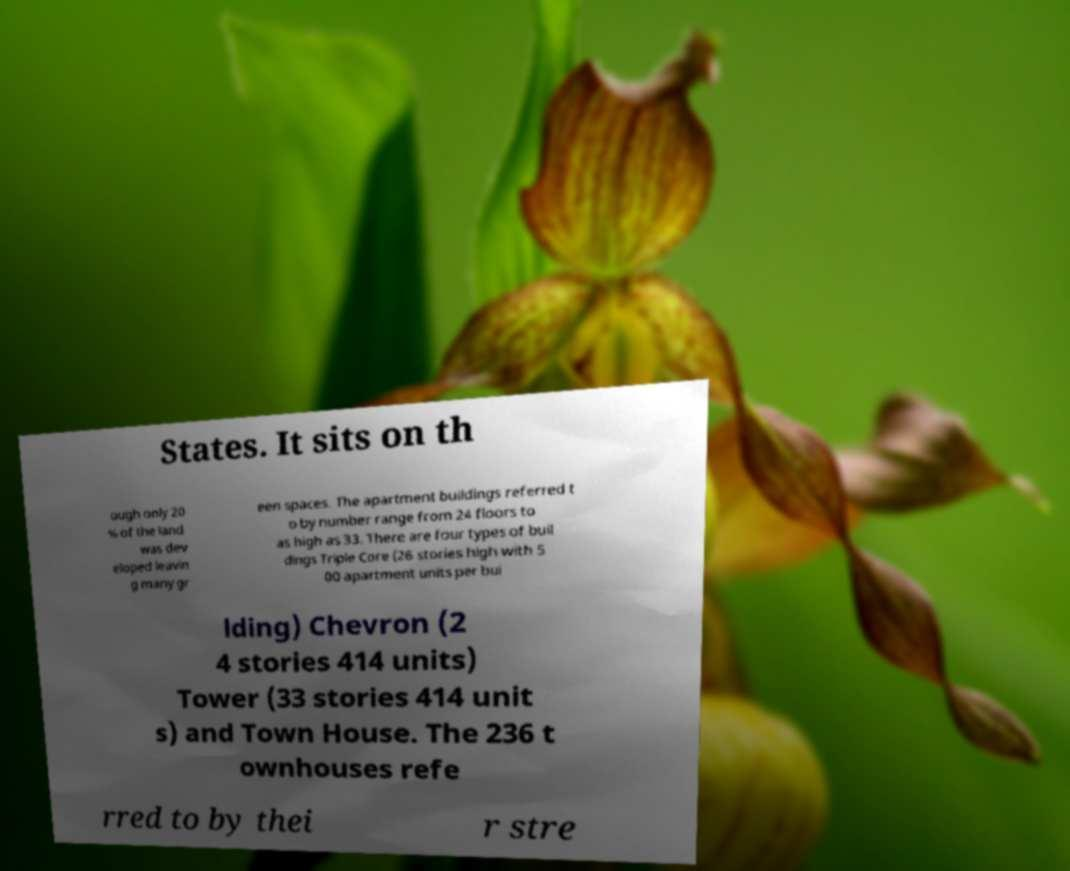Please read and relay the text visible in this image. What does it say? States. It sits on th ough only 20 % of the land was dev eloped leavin g many gr een spaces. The apartment buildings referred t o by number range from 24 floors to as high as 33. There are four types of buil dings Triple Core (26 stories high with 5 00 apartment units per bui lding) Chevron (2 4 stories 414 units) Tower (33 stories 414 unit s) and Town House. The 236 t ownhouses refe rred to by thei r stre 